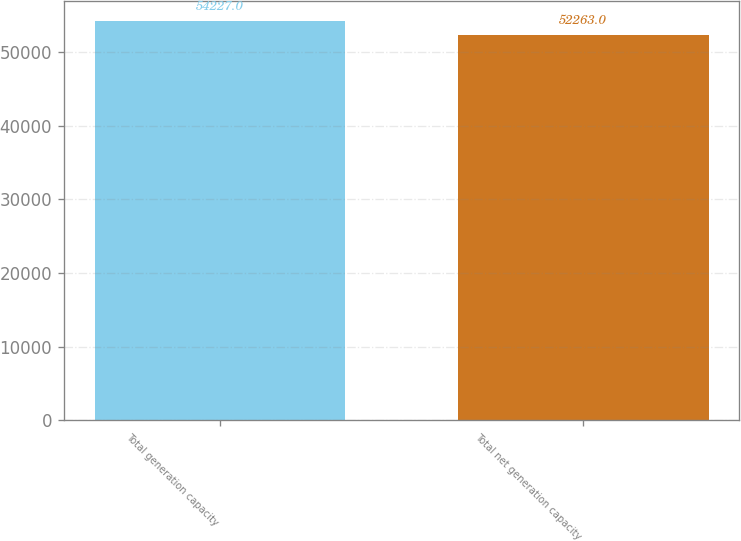Convert chart. <chart><loc_0><loc_0><loc_500><loc_500><bar_chart><fcel>Total generation capacity<fcel>Total net generation capacity<nl><fcel>54227<fcel>52263<nl></chart> 